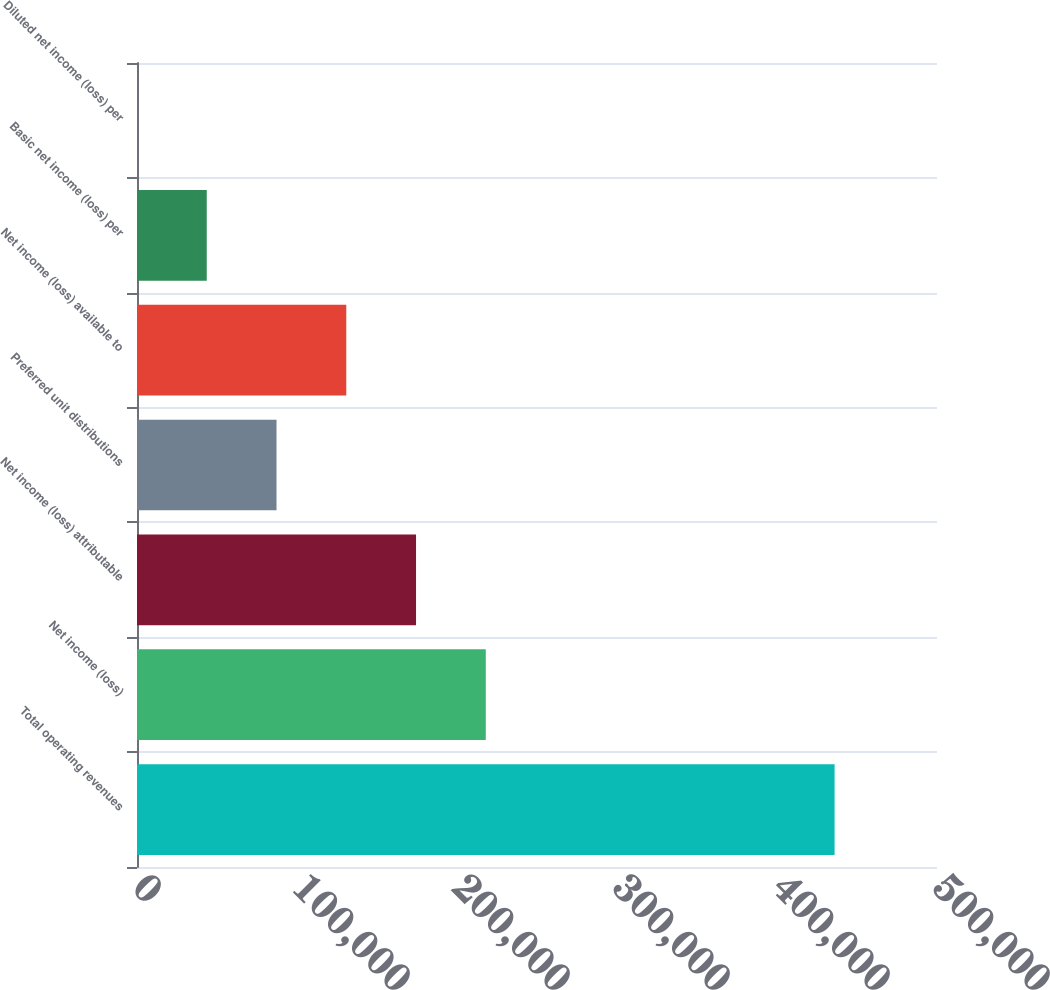Convert chart to OTSL. <chart><loc_0><loc_0><loc_500><loc_500><bar_chart><fcel>Total operating revenues<fcel>Net income (loss)<fcel>Net income (loss) attributable<fcel>Preferred unit distributions<fcel>Net income (loss) available to<fcel>Basic net income (loss) per<fcel>Diluted net income (loss) per<nl><fcel>435989<fcel>217995<fcel>174396<fcel>87198<fcel>130797<fcel>43599.1<fcel>0.27<nl></chart> 